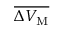<formula> <loc_0><loc_0><loc_500><loc_500>\overline { { \Delta V _ { \mathrm M } } }</formula> 